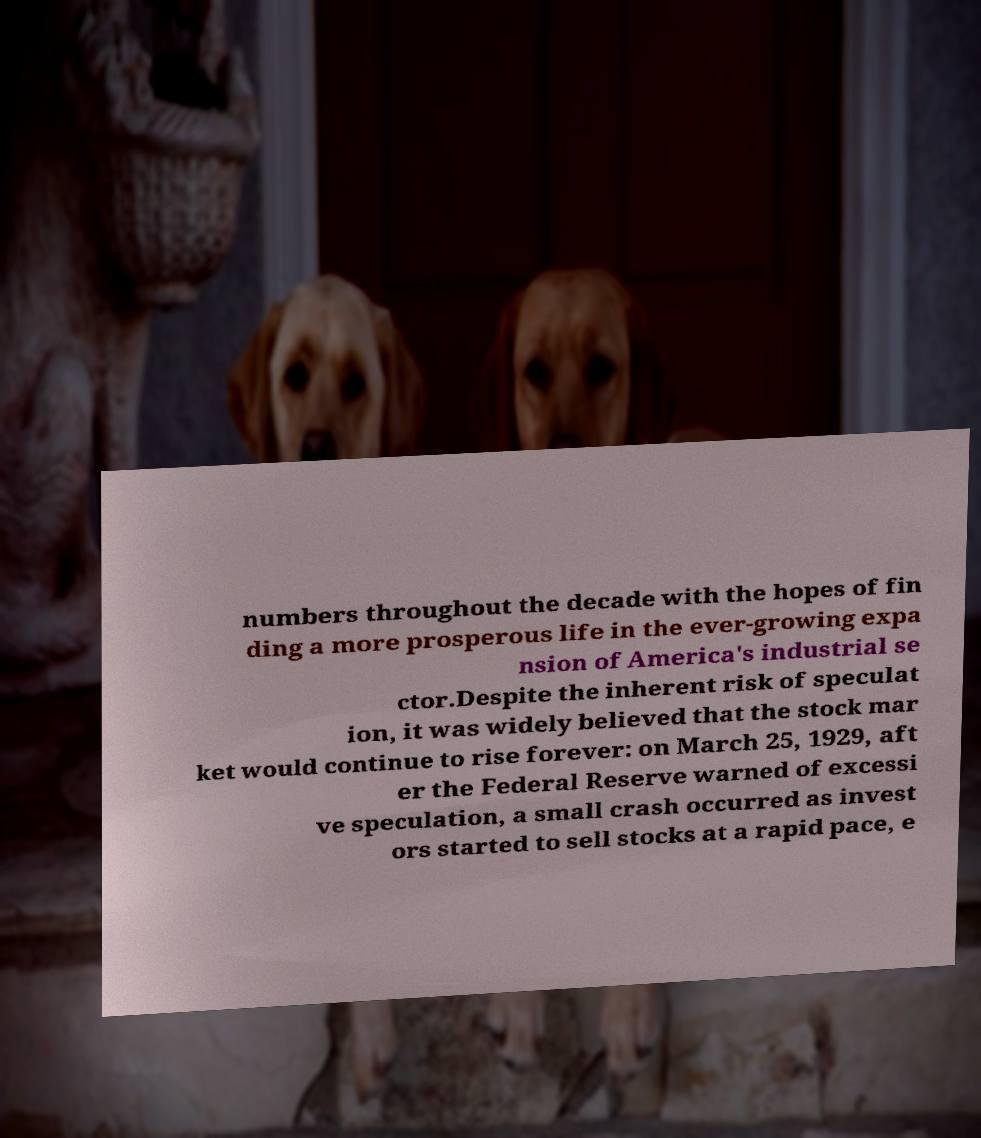Please identify and transcribe the text found in this image. numbers throughout the decade with the hopes of fin ding a more prosperous life in the ever-growing expa nsion of America's industrial se ctor.Despite the inherent risk of speculat ion, it was widely believed that the stock mar ket would continue to rise forever: on March 25, 1929, aft er the Federal Reserve warned of excessi ve speculation, a small crash occurred as invest ors started to sell stocks at a rapid pace, e 